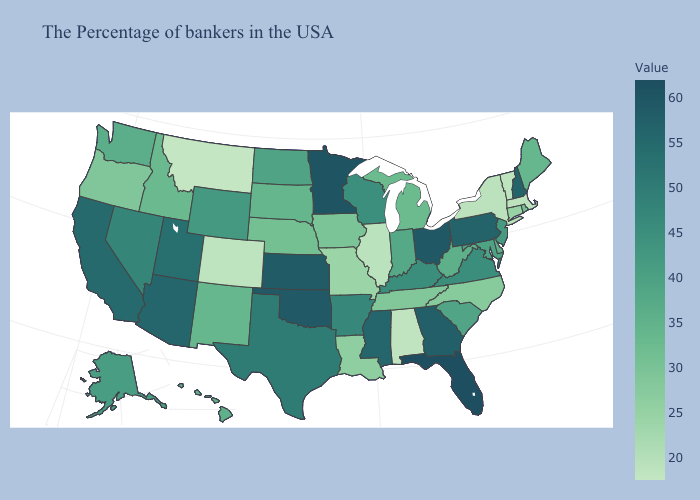Which states hav the highest value in the South?
Quick response, please. Florida. Among the states that border Georgia , which have the highest value?
Short answer required. Florida. Which states have the lowest value in the USA?
Write a very short answer. Montana. Which states have the highest value in the USA?
Quick response, please. Florida. Does the map have missing data?
Give a very brief answer. No. 